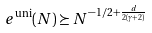<formula> <loc_0><loc_0><loc_500><loc_500>e ^ { \text {uni} } ( N ) \succeq N ^ { - 1 / 2 + { \frac { d } { 2 ( \gamma + 2 ) } } }</formula> 